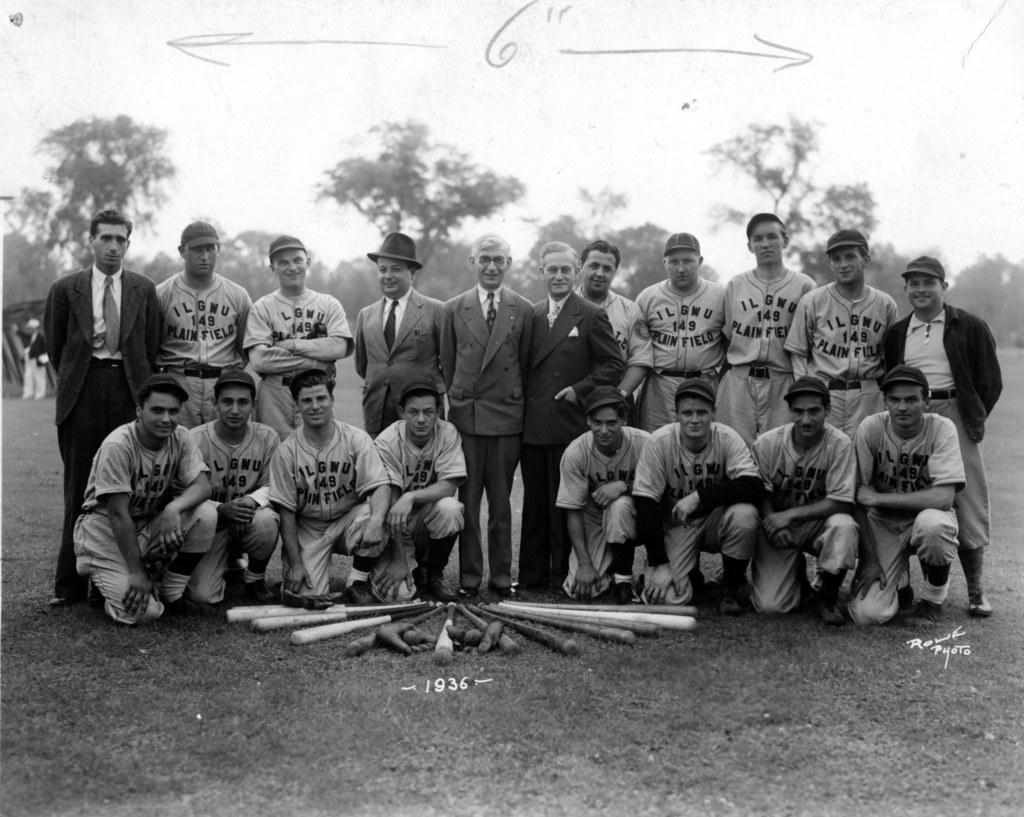How would you summarize this image in a sentence or two? This is a black and white image. In this image we can see a group of people standing on the ground and some people sitting on their knees. We can also see some baseball bats placed on the grass. On the backside we can see a group of trees and the sky. We can also see some text on this image. 